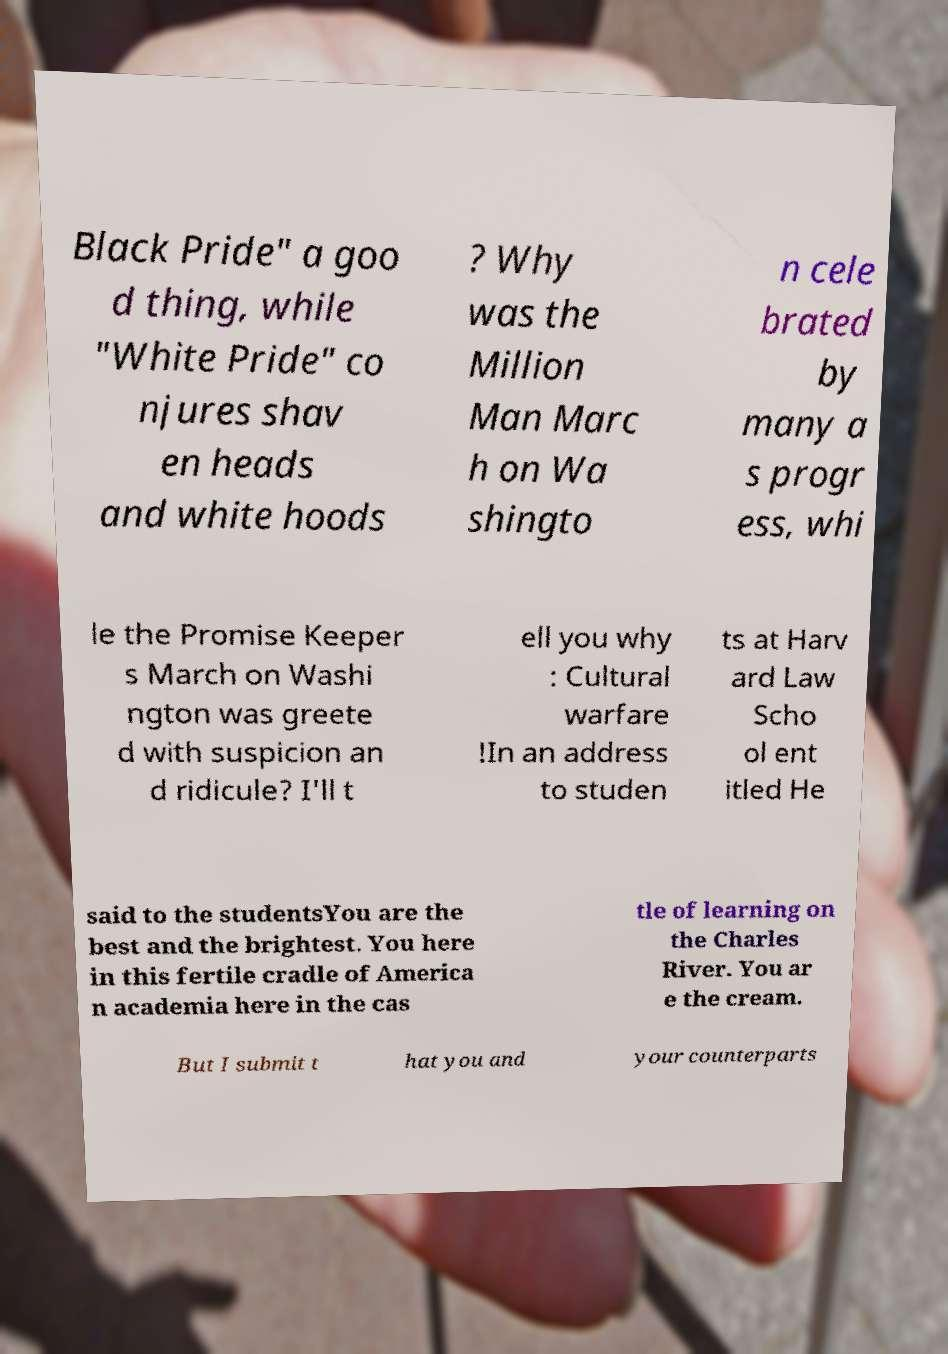Could you assist in decoding the text presented in this image and type it out clearly? Black Pride" a goo d thing, while "White Pride" co njures shav en heads and white hoods ? Why was the Million Man Marc h on Wa shingto n cele brated by many a s progr ess, whi le the Promise Keeper s March on Washi ngton was greete d with suspicion an d ridicule? I'll t ell you why : Cultural warfare !In an address to studen ts at Harv ard Law Scho ol ent itled He said to the studentsYou are the best and the brightest. You here in this fertile cradle of America n academia here in the cas tle of learning on the Charles River. You ar e the cream. But I submit t hat you and your counterparts 